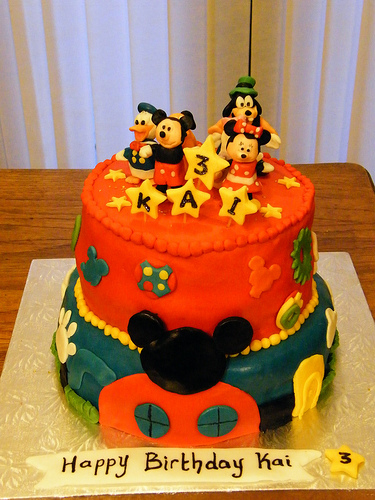<image>
Is the donald duck above the table? Yes. The donald duck is positioned above the table in the vertical space, higher up in the scene. 